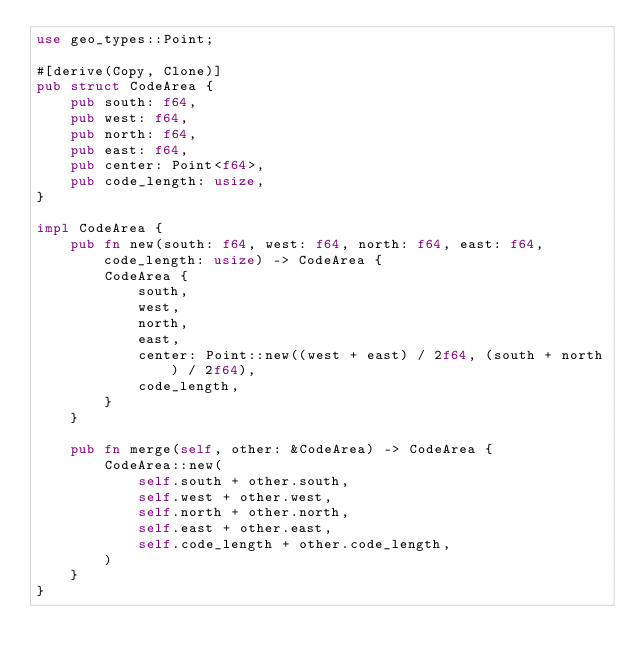Convert code to text. <code><loc_0><loc_0><loc_500><loc_500><_Rust_>use geo_types::Point;

#[derive(Copy, Clone)]
pub struct CodeArea {
    pub south: f64,
    pub west: f64,
    pub north: f64,
    pub east: f64,
    pub center: Point<f64>,
    pub code_length: usize,
}

impl CodeArea {
    pub fn new(south: f64, west: f64, north: f64, east: f64, code_length: usize) -> CodeArea {
        CodeArea {
            south,
            west,
            north,
            east,
            center: Point::new((west + east) / 2f64, (south + north) / 2f64),
            code_length,
        }
    }

    pub fn merge(self, other: &CodeArea) -> CodeArea {
        CodeArea::new(
            self.south + other.south,
            self.west + other.west,
            self.north + other.north,
            self.east + other.east,
            self.code_length + other.code_length,
        )
    }
}
</code> 